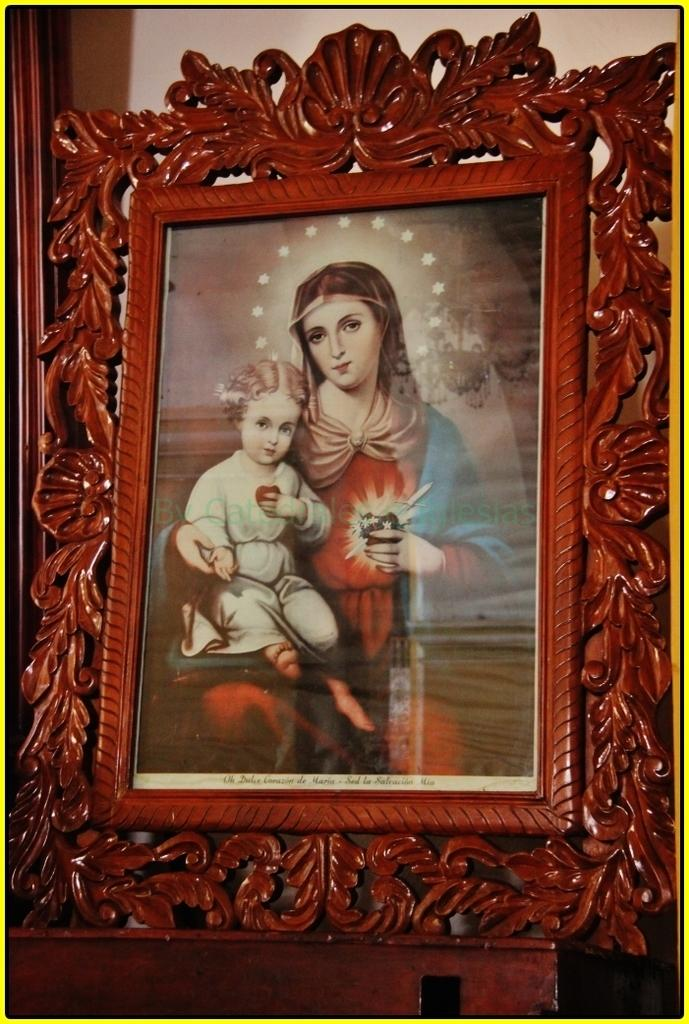What is depicted in the photo frame in the image? The image is a photo frame of Jesus with his mother. What type of surface is the photo frame placed on? The photo frame is placed on a wooden surface. Are there any design elements around the photo frame? Yes, the image has borders. What type of jam is being spread on the sofa in the image? There is no sofa or jam present in the image; it features a photo frame of Jesus and his mother placed on a wooden surface. 